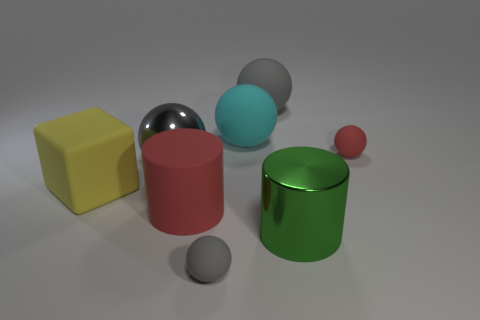Subtract all red cylinders. How many gray spheres are left? 3 Subtract all brown balls. Subtract all green cylinders. How many balls are left? 5 Add 1 big brown cylinders. How many objects exist? 9 Subtract all blocks. How many objects are left? 7 Add 3 small brown metallic balls. How many small brown metallic balls exist? 3 Subtract 0 yellow cylinders. How many objects are left? 8 Subtract all red spheres. Subtract all tiny gray objects. How many objects are left? 6 Add 5 rubber cylinders. How many rubber cylinders are left? 6 